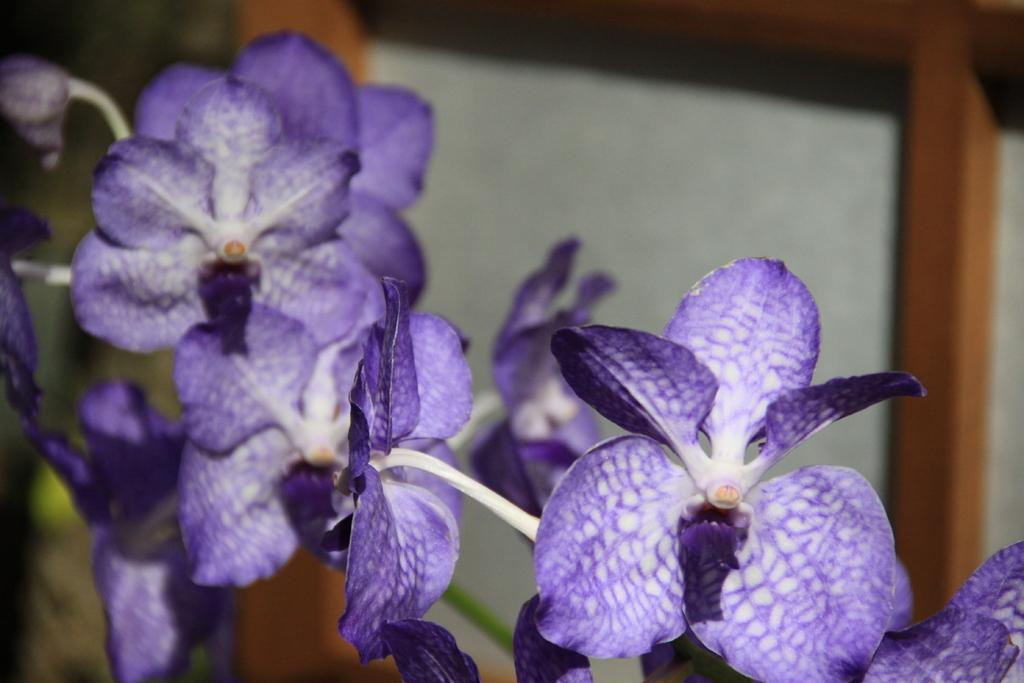What type of flowers are in the image? There are purple flowers in the image. Can you describe the background of the flowers? The background of the flowers is blurred. What type of belief is depicted in the image? There is no belief depicted in the image; it features purple flowers with a blurred background. How many apples can be seen in the image? There are no apples present in the image. 